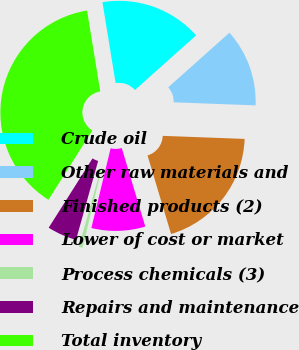<chart> <loc_0><loc_0><loc_500><loc_500><pie_chart><fcel>Crude oil<fcel>Other raw materials and<fcel>Finished products (2)<fcel>Lower of cost or market<fcel>Process chemicals (3)<fcel>Repairs and maintenance<fcel>Total inventory<nl><fcel>15.98%<fcel>12.19%<fcel>19.77%<fcel>8.41%<fcel>0.58%<fcel>4.62%<fcel>38.45%<nl></chart> 